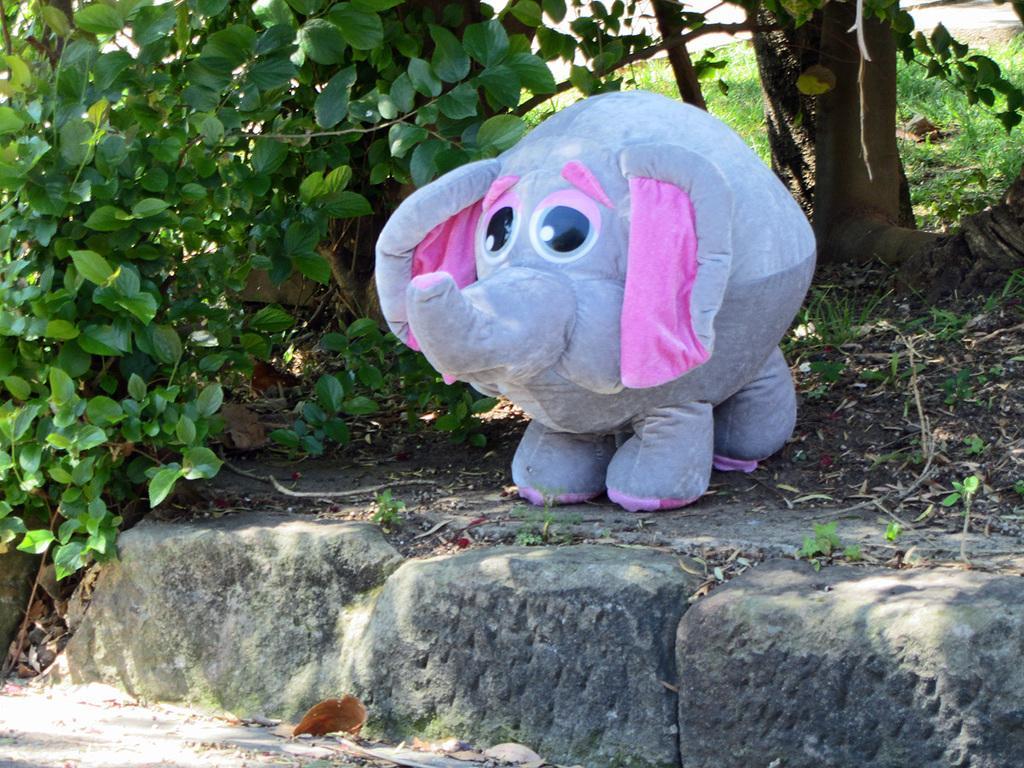Describe this image in one or two sentences. In this picture I can see a doll in the middle, there are trees in the background. At the bottom I can see the stones. 